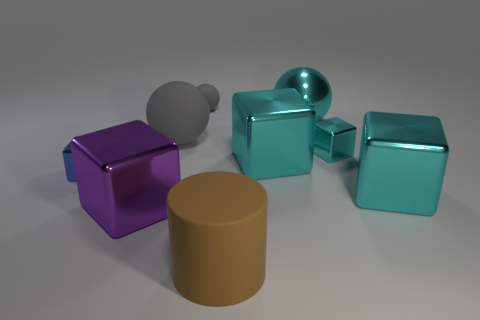Subtract all cyan cubes. How many were subtracted if there are2cyan cubes left? 1 Subtract all rubber spheres. How many spheres are left? 1 Subtract all cyan spheres. How many spheres are left? 2 Subtract all spheres. How many objects are left? 6 Subtract 1 cylinders. How many cylinders are left? 0 Add 4 gray shiny blocks. How many gray shiny blocks exist? 4 Subtract 0 green balls. How many objects are left? 9 Subtract all gray balls. Subtract all brown cylinders. How many balls are left? 1 Subtract all green spheres. How many green cubes are left? 0 Subtract all tiny blue objects. Subtract all spheres. How many objects are left? 5 